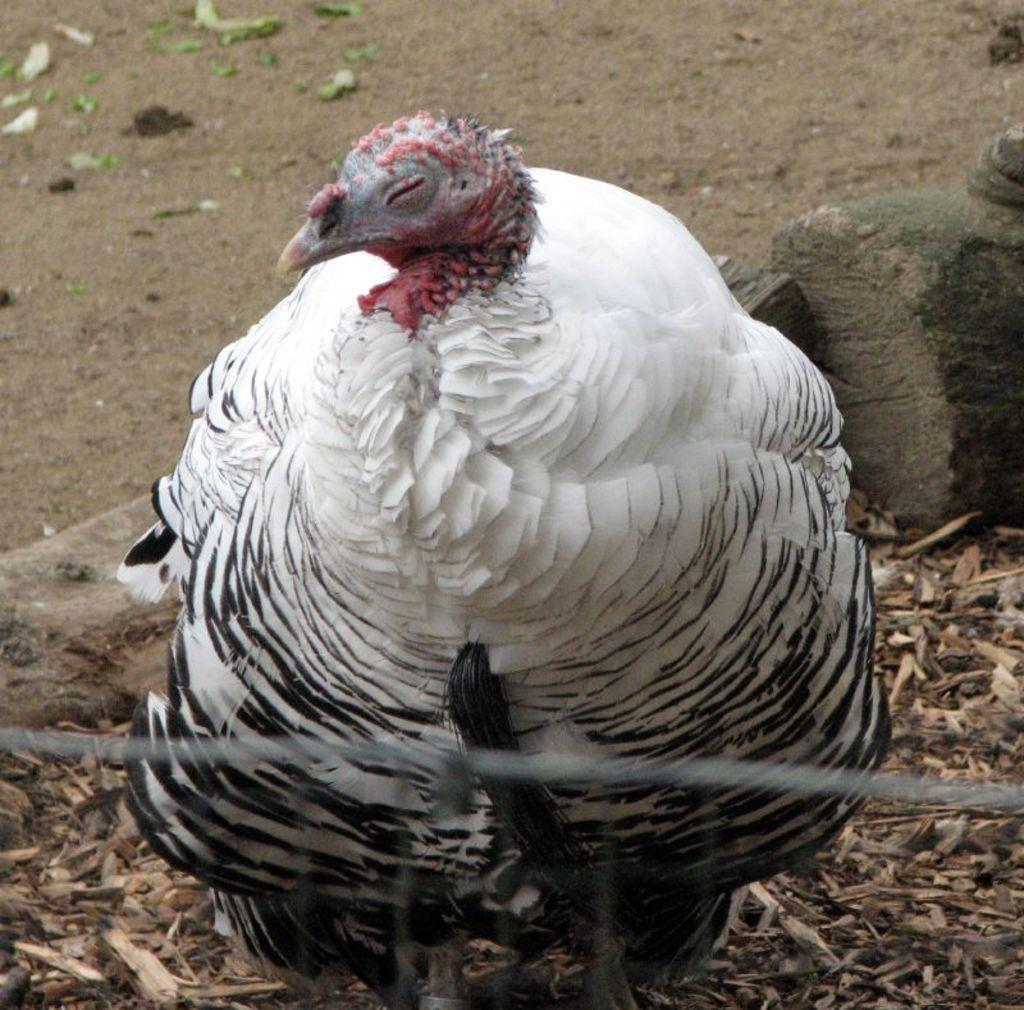What type of bird is in the image? There is a royal palm turkey in the image. What is located at the bottom of the image? There are pieces of wood at the bottom of the image. What type of material is visible in the image? There is a wire visible in the image. What type of cactus can be seen in the image? There is no cactus present in the image. What kind of trouble is the royal palm turkey experiencing in the image? The image does not depict any trouble or distress for the royal palm turkey. 